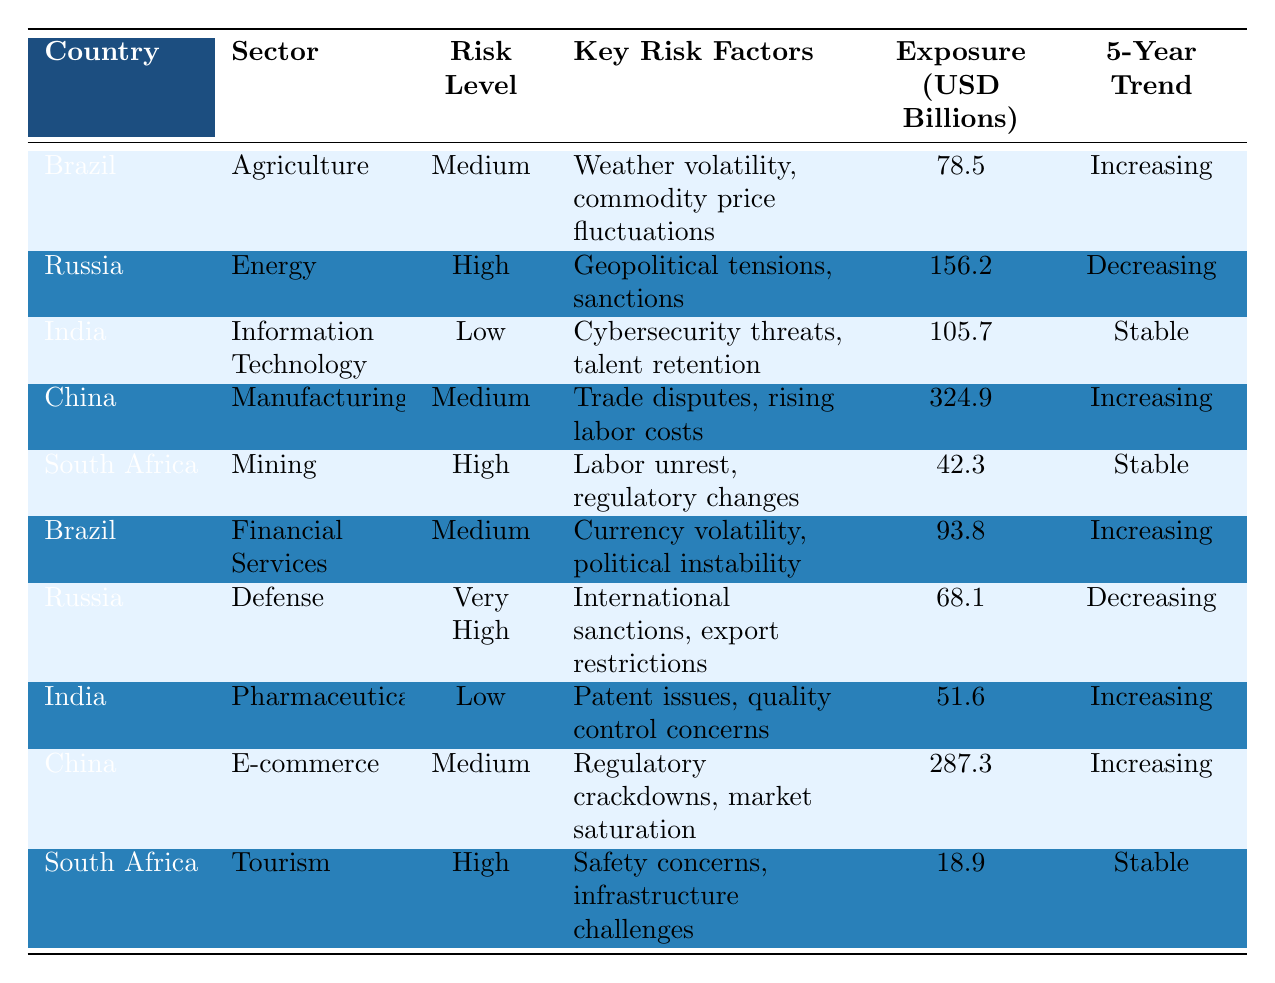What is the risk level for Brazil's Agriculture sector? According to the table, Brazil's Agriculture sector is categorized under the "Risk Level" as "Medium".
Answer: Medium Which sector in Russia has the highest risk level? The table indicates that the "Defense" sector in Russia has a "Very High" risk level, which is the highest risk classification present.
Answer: Defense What is the exposure amount for China's E-commerce sector? The table shows that the exposure amount for the E-commerce sector in China is 287.3 billion USD.
Answer: 287.3 billion USD How many sectors in South Africa are classified as having high risk? The table lists two sectors in South Africa with a "High" risk level: Mining and Tourism. Therefore, there are 2 sectors.
Answer: 2 What is the total exposure (in USD billions) for the Information Technology and Pharmaceuticals sectors in India? The Information Technology sector exposure is 105.7 billion USD and Pharmaceuticals is 51.6 billion USD. Adding these amounts gives 105.7 + 51.6 = 157.3 billion USD.
Answer: 157.3 billion USD Is the risk level for China's Manufacturing sector increasing or decreasing? The table states that the trend for China's Manufacturing sector is "Increasing".
Answer: Increasing Which sector has the lowest exposure amount, and what is the amount? By examining the exposure amounts in the table, the Tourism sector in South Africa has the lowest exposure at 18.9 billion USD.
Answer: Tourism sector, 18.9 billion USD What is the difference in exposure between the Energy sector in Russia and the Agriculture sector in Brazil? The exposure for the Energy sector in Russia is 156.2 billion USD and for Agriculture in Brazil is 78.5 billion USD. The difference is 156.2 - 78.5 = 77.7 billion USD.
Answer: 77.7 billion USD How many sectors in total have a low risk level across all countries listed? In the table, the sectors with a low risk level are Information Technology in India and Pharmaceuticals in India. Thus, there are 2 low-risk sectors in total.
Answer: 2 Which country has the highest exposure amount and in which sector? China has the highest exposure amount of 324.9 billion USD in the Manufacturing sector, as indicated in the table.
Answer: China, Manufacturing sector, 324.9 billion USD 